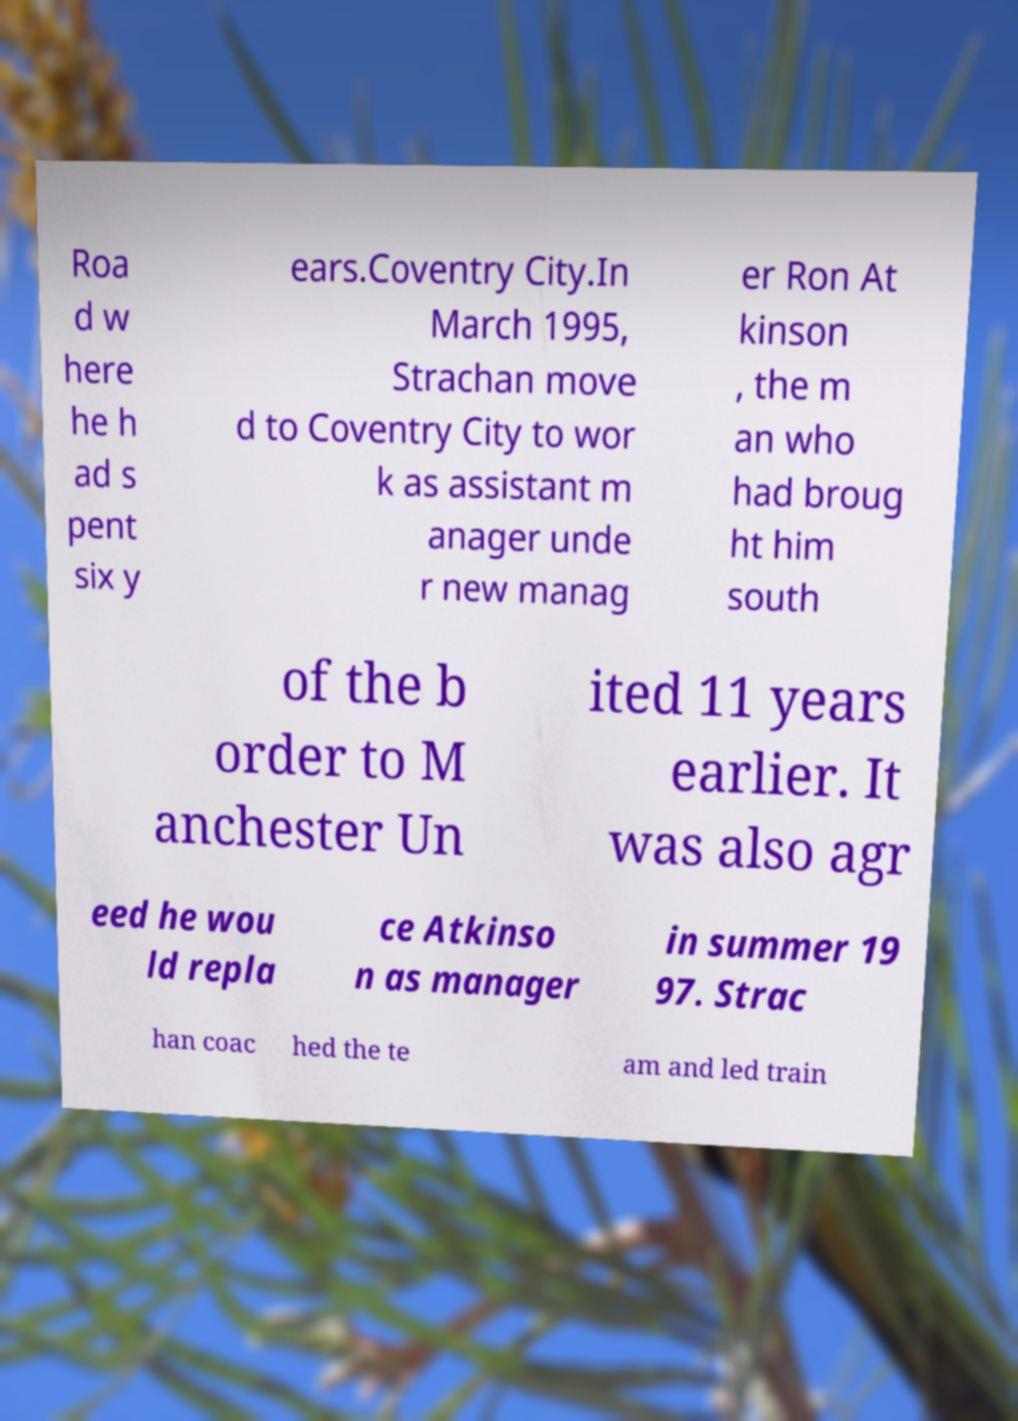Please read and relay the text visible in this image. What does it say? Roa d w here he h ad s pent six y ears.Coventry City.In March 1995, Strachan move d to Coventry City to wor k as assistant m anager unde r new manag er Ron At kinson , the m an who had broug ht him south of the b order to M anchester Un ited 11 years earlier. It was also agr eed he wou ld repla ce Atkinso n as manager in summer 19 97. Strac han coac hed the te am and led train 